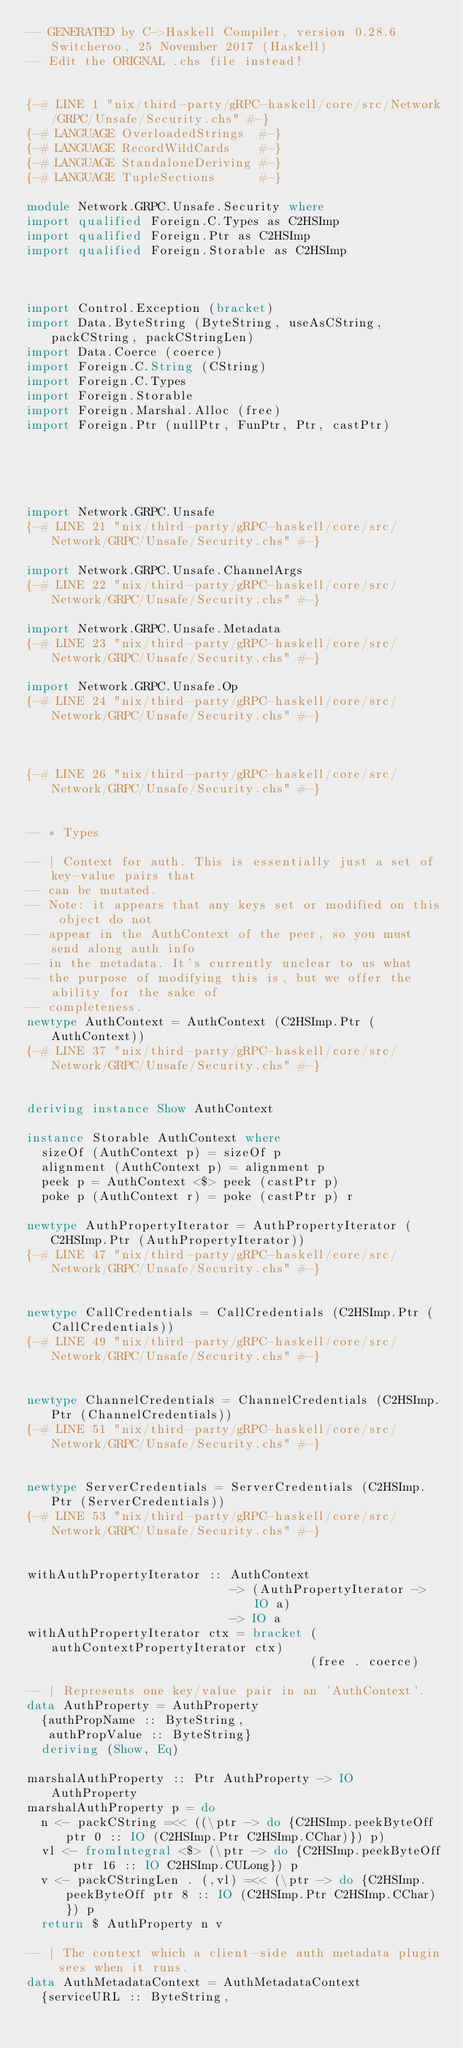<code> <loc_0><loc_0><loc_500><loc_500><_Haskell_>-- GENERATED by C->Haskell Compiler, version 0.28.6 Switcheroo, 25 November 2017 (Haskell)
-- Edit the ORIGNAL .chs file instead!


{-# LINE 1 "nix/third-party/gRPC-haskell/core/src/Network/GRPC/Unsafe/Security.chs" #-}
{-# LANGUAGE OverloadedStrings  #-}
{-# LANGUAGE RecordWildCards    #-}
{-# LANGUAGE StandaloneDeriving #-}
{-# LANGUAGE TupleSections      #-}

module Network.GRPC.Unsafe.Security where
import qualified Foreign.C.Types as C2HSImp
import qualified Foreign.Ptr as C2HSImp
import qualified Foreign.Storable as C2HSImp



import Control.Exception (bracket)
import Data.ByteString (ByteString, useAsCString, packCString, packCStringLen)
import Data.Coerce (coerce)
import Foreign.C.String (CString)
import Foreign.C.Types
import Foreign.Storable
import Foreign.Marshal.Alloc (free)
import Foreign.Ptr (nullPtr, FunPtr, Ptr, castPtr)





import Network.GRPC.Unsafe
{-# LINE 21 "nix/third-party/gRPC-haskell/core/src/Network/GRPC/Unsafe/Security.chs" #-}

import Network.GRPC.Unsafe.ChannelArgs
{-# LINE 22 "nix/third-party/gRPC-haskell/core/src/Network/GRPC/Unsafe/Security.chs" #-}

import Network.GRPC.Unsafe.Metadata
{-# LINE 23 "nix/third-party/gRPC-haskell/core/src/Network/GRPC/Unsafe/Security.chs" #-}

import Network.GRPC.Unsafe.Op
{-# LINE 24 "nix/third-party/gRPC-haskell/core/src/Network/GRPC/Unsafe/Security.chs" #-}



{-# LINE 26 "nix/third-party/gRPC-haskell/core/src/Network/GRPC/Unsafe/Security.chs" #-}


-- * Types

-- | Context for auth. This is essentially just a set of key-value pairs that
-- can be mutated.
-- Note: it appears that any keys set or modified on this object do not
-- appear in the AuthContext of the peer, so you must send along auth info
-- in the metadata. It's currently unclear to us what
-- the purpose of modifying this is, but we offer the ability for the sake of
-- completeness.
newtype AuthContext = AuthContext (C2HSImp.Ptr (AuthContext))
{-# LINE 37 "nix/third-party/gRPC-haskell/core/src/Network/GRPC/Unsafe/Security.chs" #-}


deriving instance Show AuthContext

instance Storable AuthContext where
  sizeOf (AuthContext p) = sizeOf p
  alignment (AuthContext p) = alignment p
  peek p = AuthContext <$> peek (castPtr p)
  poke p (AuthContext r) = poke (castPtr p) r

newtype AuthPropertyIterator = AuthPropertyIterator (C2HSImp.Ptr (AuthPropertyIterator))
{-# LINE 47 "nix/third-party/gRPC-haskell/core/src/Network/GRPC/Unsafe/Security.chs" #-}


newtype CallCredentials = CallCredentials (C2HSImp.Ptr (CallCredentials))
{-# LINE 49 "nix/third-party/gRPC-haskell/core/src/Network/GRPC/Unsafe/Security.chs" #-}


newtype ChannelCredentials = ChannelCredentials (C2HSImp.Ptr (ChannelCredentials))
{-# LINE 51 "nix/third-party/gRPC-haskell/core/src/Network/GRPC/Unsafe/Security.chs" #-}


newtype ServerCredentials = ServerCredentials (C2HSImp.Ptr (ServerCredentials))
{-# LINE 53 "nix/third-party/gRPC-haskell/core/src/Network/GRPC/Unsafe/Security.chs" #-}


withAuthPropertyIterator :: AuthContext
                            -> (AuthPropertyIterator -> IO a)
                            -> IO a
withAuthPropertyIterator ctx = bracket (authContextPropertyIterator ctx)
                                       (free . coerce)

-- | Represents one key/value pair in an 'AuthContext'.
data AuthProperty = AuthProperty
  {authPropName :: ByteString,
   authPropValue :: ByteString}
  deriving (Show, Eq)

marshalAuthProperty :: Ptr AuthProperty -> IO AuthProperty
marshalAuthProperty p = do
  n <- packCString =<< ((\ptr -> do {C2HSImp.peekByteOff ptr 0 :: IO (C2HSImp.Ptr C2HSImp.CChar)}) p)
  vl <- fromIntegral <$> (\ptr -> do {C2HSImp.peekByteOff ptr 16 :: IO C2HSImp.CULong}) p
  v <- packCStringLen . (,vl) =<< (\ptr -> do {C2HSImp.peekByteOff ptr 8 :: IO (C2HSImp.Ptr C2HSImp.CChar)}) p
  return $ AuthProperty n v

-- | The context which a client-side auth metadata plugin sees when it runs.
data AuthMetadataContext = AuthMetadataContext
  {serviceURL :: ByteString,</code> 